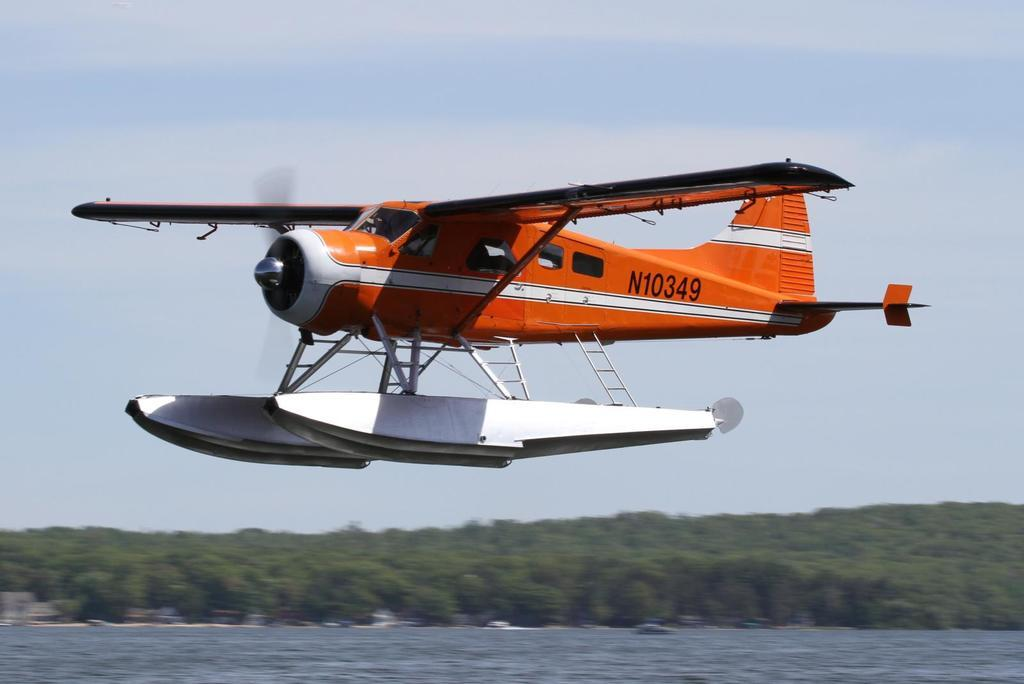<image>
Relay a brief, clear account of the picture shown. A plane with pontoons and the identifier N10349 comes in for a landing on the water. 